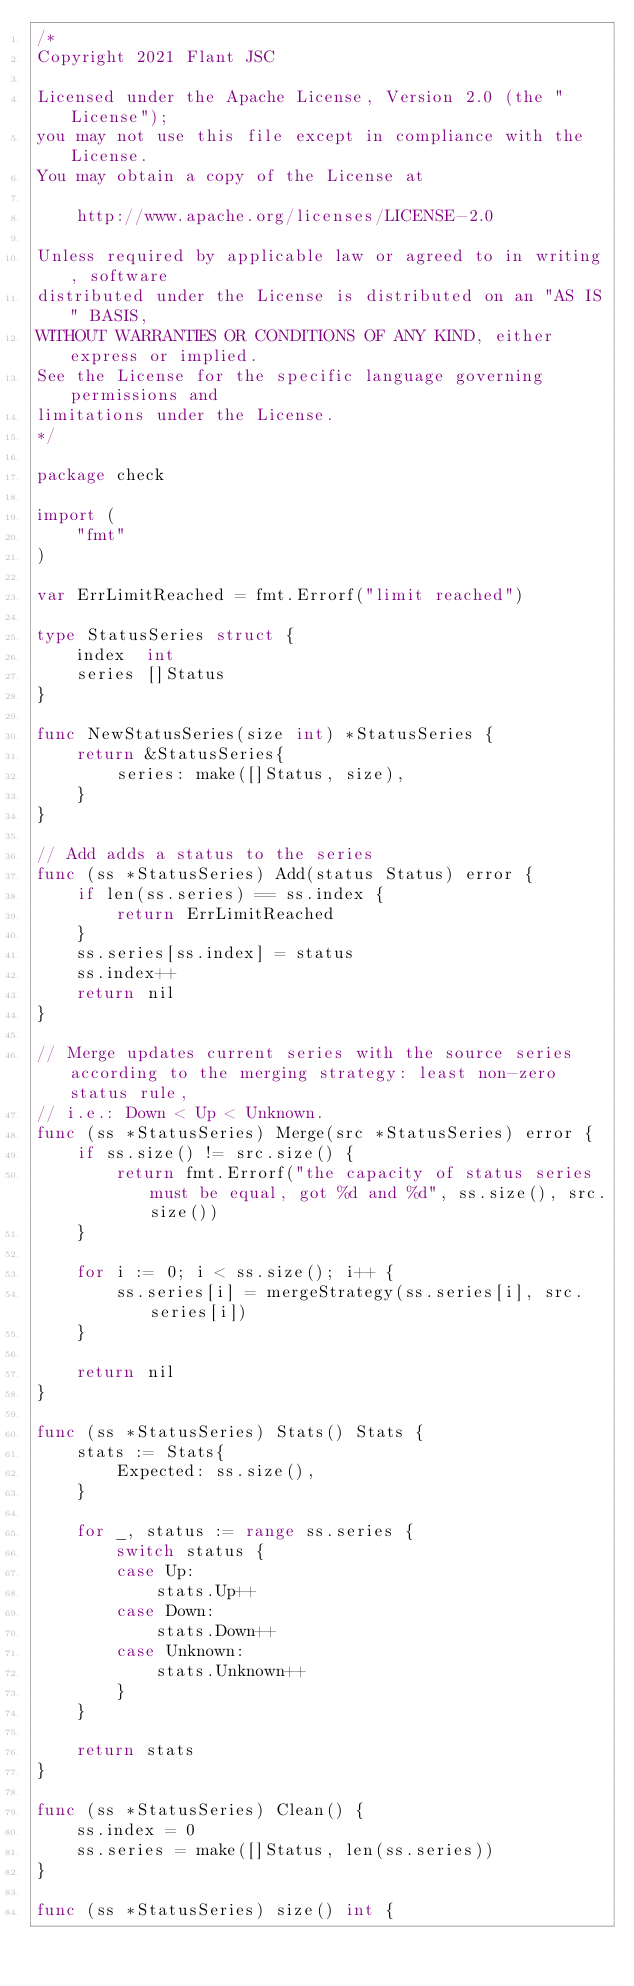Convert code to text. <code><loc_0><loc_0><loc_500><loc_500><_Go_>/*
Copyright 2021 Flant JSC

Licensed under the Apache License, Version 2.0 (the "License");
you may not use this file except in compliance with the License.
You may obtain a copy of the License at

    http://www.apache.org/licenses/LICENSE-2.0

Unless required by applicable law or agreed to in writing, software
distributed under the License is distributed on an "AS IS" BASIS,
WITHOUT WARRANTIES OR CONDITIONS OF ANY KIND, either express or implied.
See the License for the specific language governing permissions and
limitations under the License.
*/

package check

import (
	"fmt"
)

var ErrLimitReached = fmt.Errorf("limit reached")

type StatusSeries struct {
	index  int
	series []Status
}

func NewStatusSeries(size int) *StatusSeries {
	return &StatusSeries{
		series: make([]Status, size),
	}
}

// Add adds a status to the series
func (ss *StatusSeries) Add(status Status) error {
	if len(ss.series) == ss.index {
		return ErrLimitReached
	}
	ss.series[ss.index] = status
	ss.index++
	return nil
}

// Merge updates current series with the source series according to the merging strategy: least non-zero status rule,
// i.e.: Down < Up < Unknown.
func (ss *StatusSeries) Merge(src *StatusSeries) error {
	if ss.size() != src.size() {
		return fmt.Errorf("the capacity of status series must be equal, got %d and %d", ss.size(), src.size())
	}

	for i := 0; i < ss.size(); i++ {
		ss.series[i] = mergeStrategy(ss.series[i], src.series[i])
	}

	return nil
}

func (ss *StatusSeries) Stats() Stats {
	stats := Stats{
		Expected: ss.size(),
	}

	for _, status := range ss.series {
		switch status {
		case Up:
			stats.Up++
		case Down:
			stats.Down++
		case Unknown:
			stats.Unknown++
		}
	}

	return stats
}

func (ss *StatusSeries) Clean() {
	ss.index = 0
	ss.series = make([]Status, len(ss.series))
}

func (ss *StatusSeries) size() int {</code> 